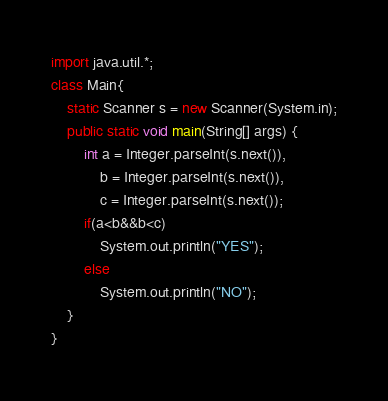Convert code to text. <code><loc_0><loc_0><loc_500><loc_500><_Java_>import java.util.*;
class Main{
	static Scanner s = new Scanner(System.in);
	public static void main(String[] args) {
		int a = Integer.parseInt(s.next()),
		    b = Integer.parseInt(s.next()),
		    c = Integer.parseInt(s.next());
		if(a<b&&b<c)
			System.out.println("YES");
		else
			System.out.println("NO");
	}
}</code> 